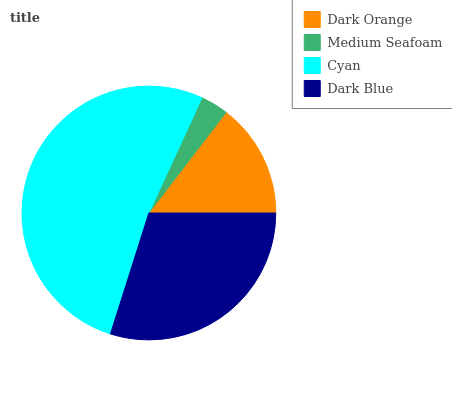Is Medium Seafoam the minimum?
Answer yes or no. Yes. Is Cyan the maximum?
Answer yes or no. Yes. Is Cyan the minimum?
Answer yes or no. No. Is Medium Seafoam the maximum?
Answer yes or no. No. Is Cyan greater than Medium Seafoam?
Answer yes or no. Yes. Is Medium Seafoam less than Cyan?
Answer yes or no. Yes. Is Medium Seafoam greater than Cyan?
Answer yes or no. No. Is Cyan less than Medium Seafoam?
Answer yes or no. No. Is Dark Blue the high median?
Answer yes or no. Yes. Is Dark Orange the low median?
Answer yes or no. Yes. Is Cyan the high median?
Answer yes or no. No. Is Cyan the low median?
Answer yes or no. No. 